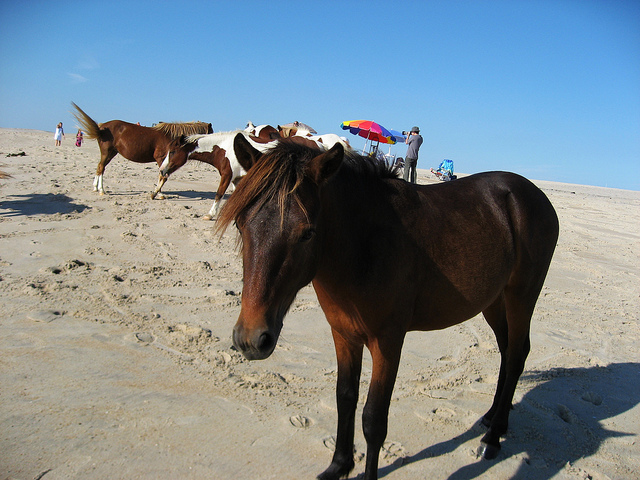What is the behavior of the horses on the beach? Do they interact with the people? The horses appear to be quite at ease on the beach, showing no signs of distress or aggressive interaction with the people around. They seem to be accustomed to human presence, possibly indicating they are part of a managed herd in a region where horses are allowed to roam freely on the beach. 